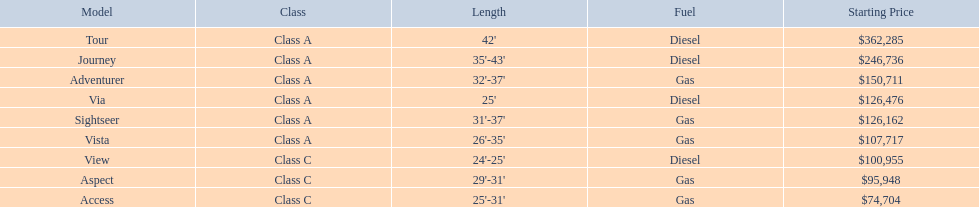What are the cost levels? $362,285, $246,736, $150,711, $126,476, $126,162, $107,717, $100,955, $95,948, $74,704. What is the highest cost? $362,285. Which version has this cost? Tour. 